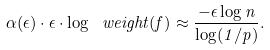<formula> <loc_0><loc_0><loc_500><loc_500>\alpha ( \epsilon ) \cdot \epsilon \cdot \log \ w e i g h t ( f ) \approx \frac { - \epsilon \log n } { \log ( 1 / p ) } .</formula> 